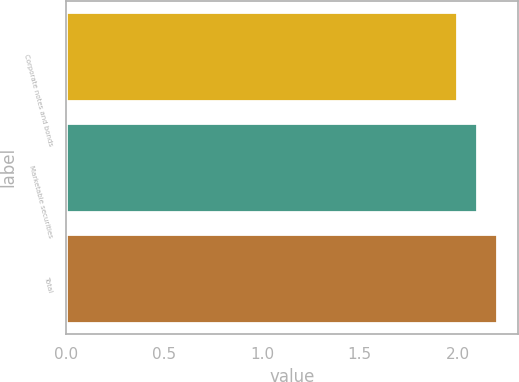Convert chart to OTSL. <chart><loc_0><loc_0><loc_500><loc_500><bar_chart><fcel>Corporate notes and bonds<fcel>Marketable securities<fcel>Total<nl><fcel>2<fcel>2.1<fcel>2.2<nl></chart> 